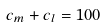<formula> <loc_0><loc_0><loc_500><loc_500>c _ { m } + c _ { l } = 1 0 0</formula> 